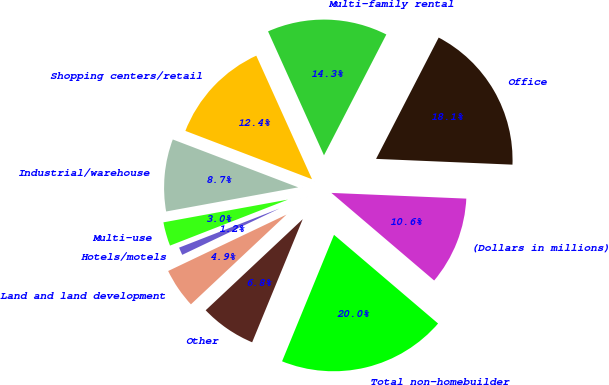<chart> <loc_0><loc_0><loc_500><loc_500><pie_chart><fcel>(Dollars in millions)<fcel>Office<fcel>Multi-family rental<fcel>Shopping centers/retail<fcel>Industrial/warehouse<fcel>Multi-use<fcel>Hotels/motels<fcel>Land and land development<fcel>Other<fcel>Total non-homebuilder<nl><fcel>10.56%<fcel>18.09%<fcel>14.33%<fcel>12.45%<fcel>8.68%<fcel>3.04%<fcel>1.16%<fcel>4.92%<fcel>6.8%<fcel>19.97%<nl></chart> 